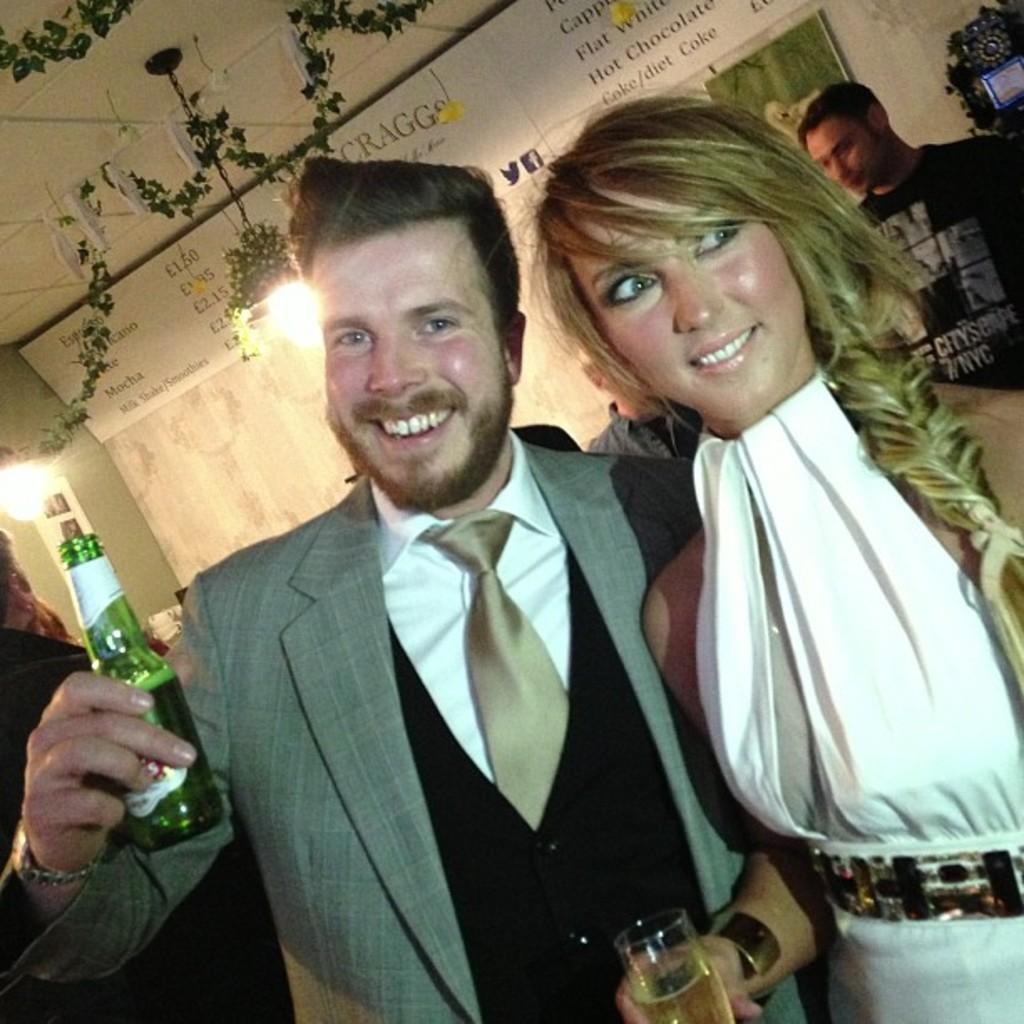Describe this image in one or two sentences. 2 people are standing. the person at the right is wearing a white dress and holding a glass of drink. the person at the left is holding a bottle. behind them there is a wall and at right corner there is a person in black t shirt 